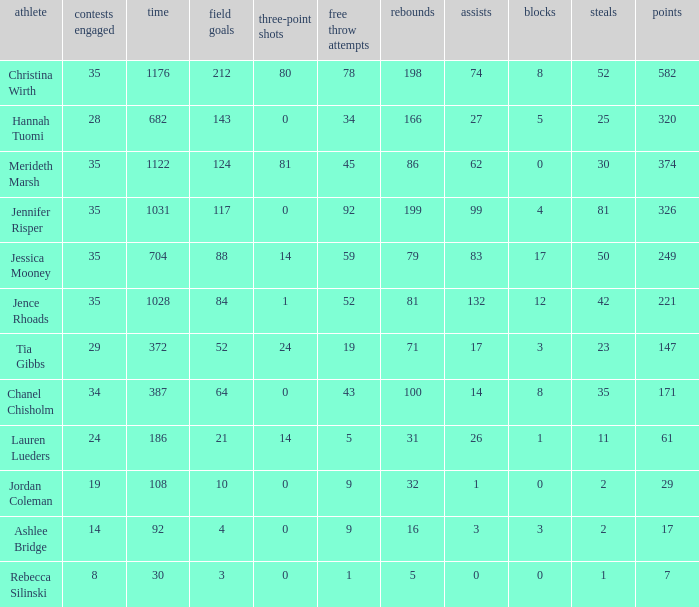What is the lowest number of 3 pointers that occured in games with 52 steals? 80.0. 